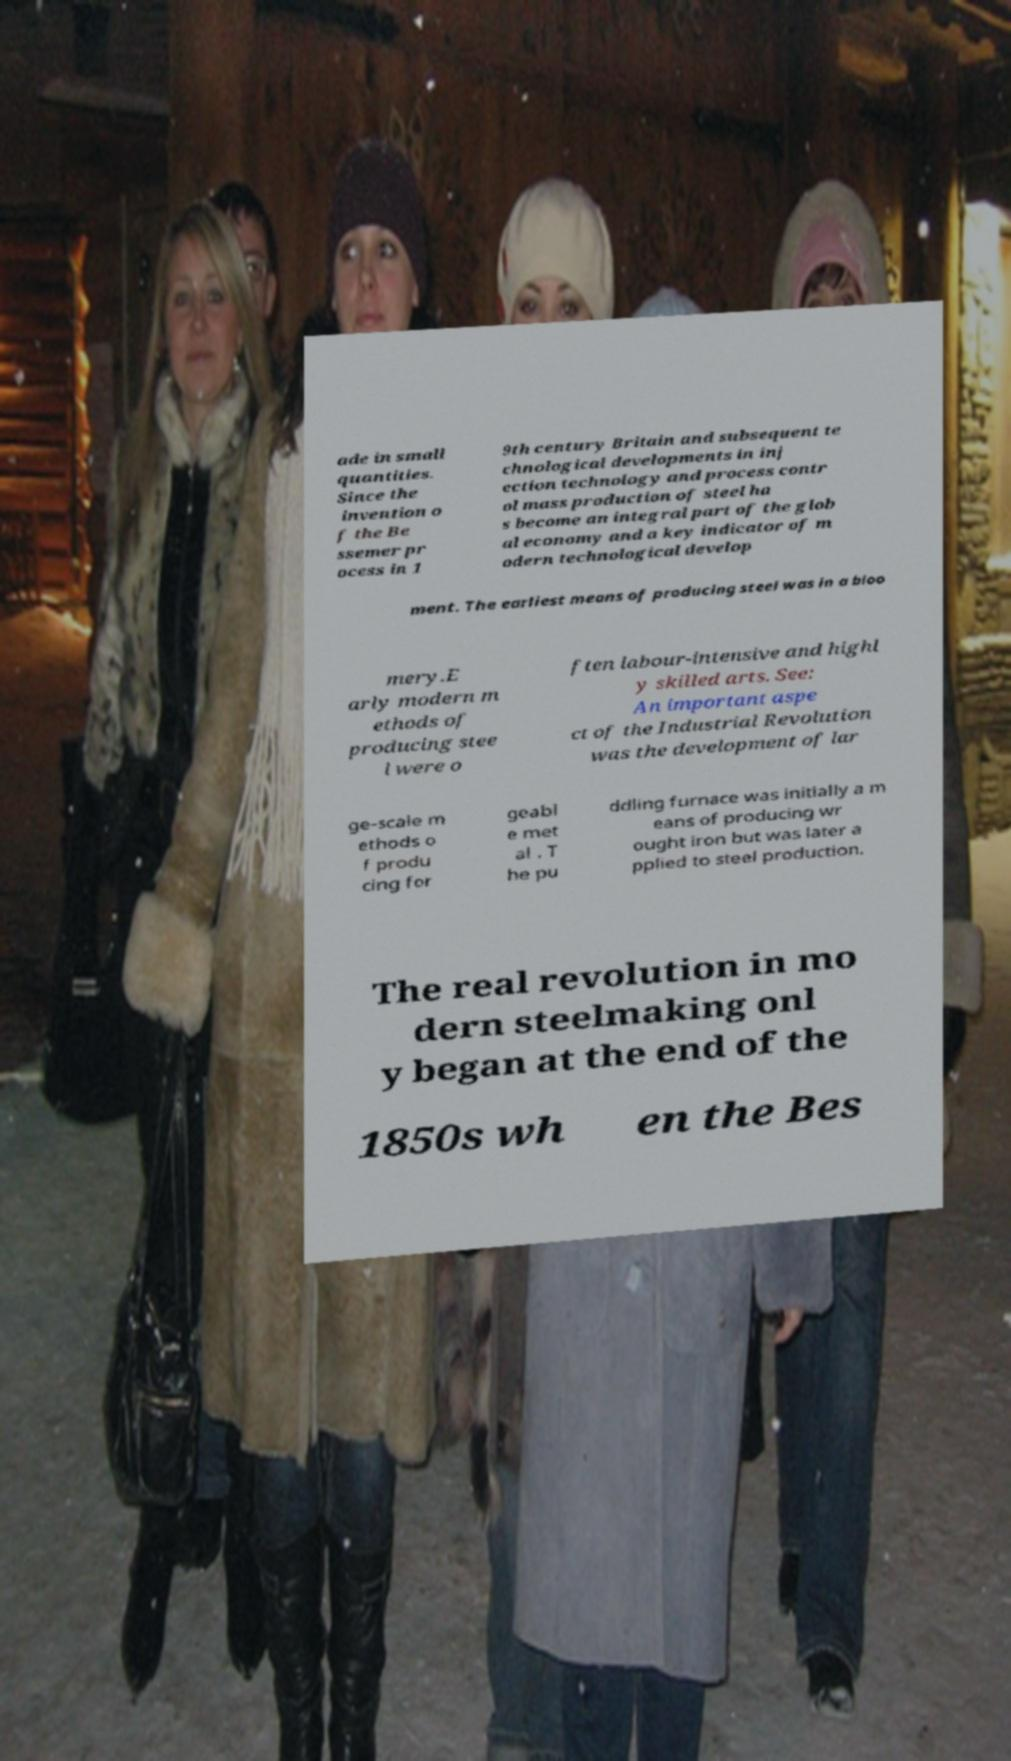I need the written content from this picture converted into text. Can you do that? ade in small quantities. Since the invention o f the Be ssemer pr ocess in 1 9th century Britain and subsequent te chnological developments in inj ection technology and process contr ol mass production of steel ha s become an integral part of the glob al economy and a key indicator of m odern technological develop ment. The earliest means of producing steel was in a bloo mery.E arly modern m ethods of producing stee l were o ften labour-intensive and highl y skilled arts. See: An important aspe ct of the Industrial Revolution was the development of lar ge-scale m ethods o f produ cing for geabl e met al . T he pu ddling furnace was initially a m eans of producing wr ought iron but was later a pplied to steel production. The real revolution in mo dern steelmaking onl y began at the end of the 1850s wh en the Bes 